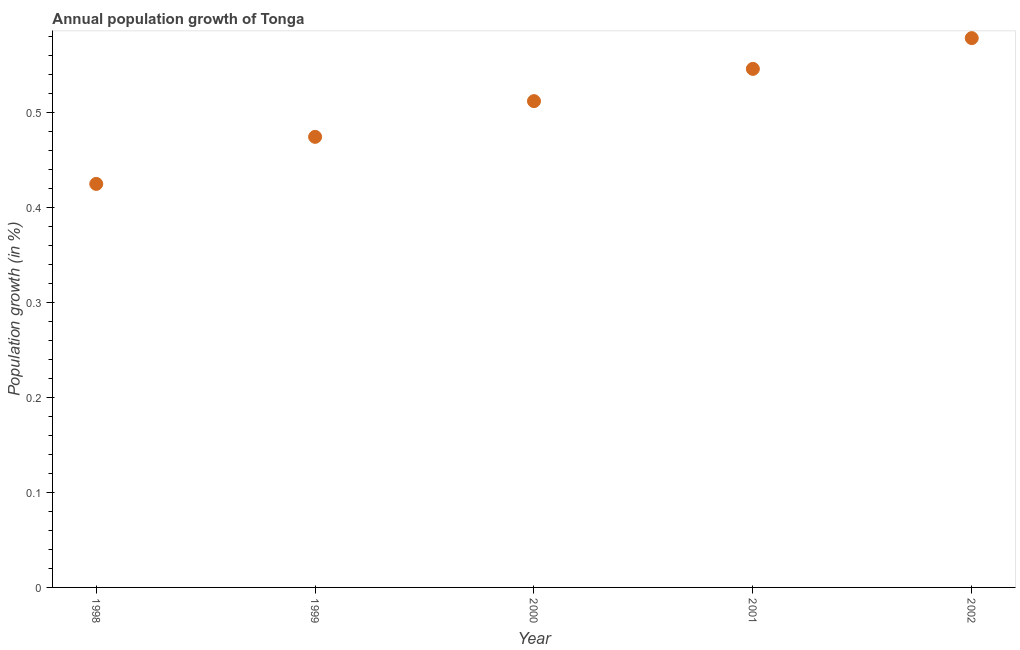What is the population growth in 2002?
Ensure brevity in your answer.  0.58. Across all years, what is the maximum population growth?
Offer a terse response. 0.58. Across all years, what is the minimum population growth?
Your answer should be compact. 0.42. In which year was the population growth maximum?
Your answer should be very brief. 2002. In which year was the population growth minimum?
Your answer should be very brief. 1998. What is the sum of the population growth?
Your response must be concise. 2.54. What is the difference between the population growth in 1998 and 1999?
Provide a succinct answer. -0.05. What is the average population growth per year?
Make the answer very short. 0.51. What is the median population growth?
Offer a very short reply. 0.51. In how many years, is the population growth greater than 0.5 %?
Make the answer very short. 3. What is the ratio of the population growth in 2000 to that in 2001?
Ensure brevity in your answer.  0.94. Is the difference between the population growth in 1999 and 2002 greater than the difference between any two years?
Give a very brief answer. No. What is the difference between the highest and the second highest population growth?
Provide a succinct answer. 0.03. What is the difference between the highest and the lowest population growth?
Your answer should be very brief. 0.15. In how many years, is the population growth greater than the average population growth taken over all years?
Make the answer very short. 3. Does the population growth monotonically increase over the years?
Your answer should be very brief. Yes. How many dotlines are there?
Offer a very short reply. 1. What is the difference between two consecutive major ticks on the Y-axis?
Offer a very short reply. 0.1. Does the graph contain any zero values?
Provide a short and direct response. No. What is the title of the graph?
Your response must be concise. Annual population growth of Tonga. What is the label or title of the X-axis?
Keep it short and to the point. Year. What is the label or title of the Y-axis?
Make the answer very short. Population growth (in %). What is the Population growth (in %) in 1998?
Your response must be concise. 0.42. What is the Population growth (in %) in 1999?
Your response must be concise. 0.47. What is the Population growth (in %) in 2000?
Your answer should be compact. 0.51. What is the Population growth (in %) in 2001?
Provide a short and direct response. 0.55. What is the Population growth (in %) in 2002?
Your response must be concise. 0.58. What is the difference between the Population growth (in %) in 1998 and 1999?
Offer a very short reply. -0.05. What is the difference between the Population growth (in %) in 1998 and 2000?
Keep it short and to the point. -0.09. What is the difference between the Population growth (in %) in 1998 and 2001?
Provide a succinct answer. -0.12. What is the difference between the Population growth (in %) in 1998 and 2002?
Keep it short and to the point. -0.15. What is the difference between the Population growth (in %) in 1999 and 2000?
Offer a very short reply. -0.04. What is the difference between the Population growth (in %) in 1999 and 2001?
Give a very brief answer. -0.07. What is the difference between the Population growth (in %) in 1999 and 2002?
Offer a very short reply. -0.1. What is the difference between the Population growth (in %) in 2000 and 2001?
Your answer should be compact. -0.03. What is the difference between the Population growth (in %) in 2000 and 2002?
Provide a succinct answer. -0.07. What is the difference between the Population growth (in %) in 2001 and 2002?
Ensure brevity in your answer.  -0.03. What is the ratio of the Population growth (in %) in 1998 to that in 1999?
Your answer should be very brief. 0.9. What is the ratio of the Population growth (in %) in 1998 to that in 2000?
Keep it short and to the point. 0.83. What is the ratio of the Population growth (in %) in 1998 to that in 2001?
Offer a very short reply. 0.78. What is the ratio of the Population growth (in %) in 1998 to that in 2002?
Provide a succinct answer. 0.73. What is the ratio of the Population growth (in %) in 1999 to that in 2000?
Make the answer very short. 0.93. What is the ratio of the Population growth (in %) in 1999 to that in 2001?
Your answer should be very brief. 0.87. What is the ratio of the Population growth (in %) in 1999 to that in 2002?
Offer a very short reply. 0.82. What is the ratio of the Population growth (in %) in 2000 to that in 2001?
Your answer should be compact. 0.94. What is the ratio of the Population growth (in %) in 2000 to that in 2002?
Give a very brief answer. 0.89. What is the ratio of the Population growth (in %) in 2001 to that in 2002?
Keep it short and to the point. 0.94. 